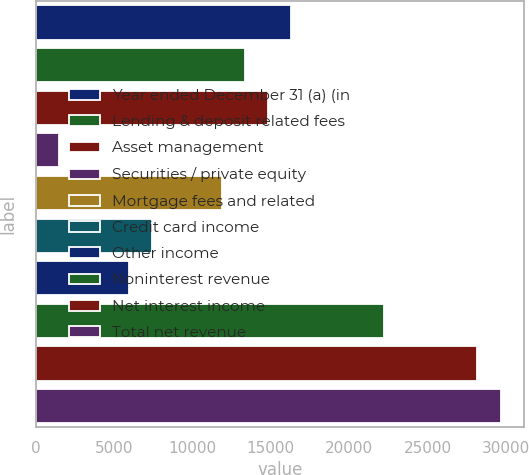Convert chart to OTSL. <chart><loc_0><loc_0><loc_500><loc_500><bar_chart><fcel>Year ended December 31 (a) (in<fcel>Lending & deposit related fees<fcel>Asset management<fcel>Securities / private equity<fcel>Mortgage fees and related<fcel>Credit card income<fcel>Other income<fcel>Noninterest revenue<fcel>Net interest income<fcel>Total net revenue<nl><fcel>16312.9<fcel>13347.2<fcel>14830<fcel>1484.36<fcel>11864.3<fcel>7415.76<fcel>5932.91<fcel>22244.3<fcel>28175.7<fcel>29658.5<nl></chart> 